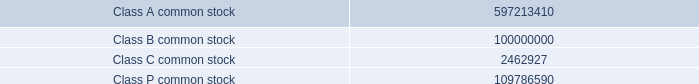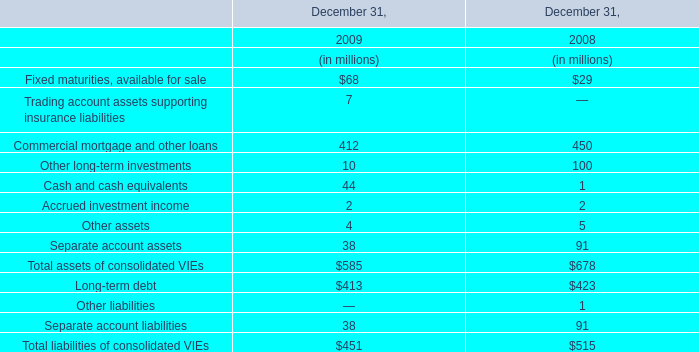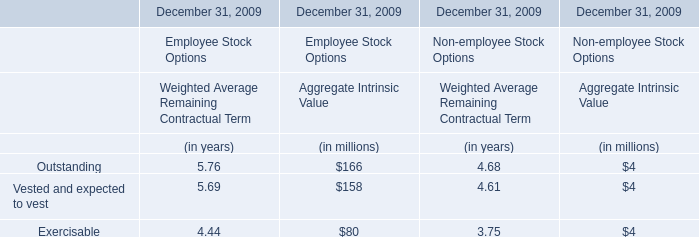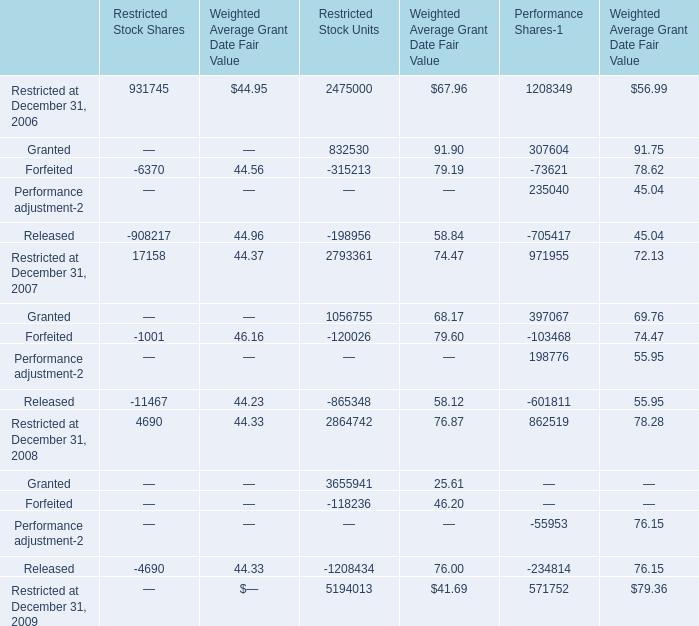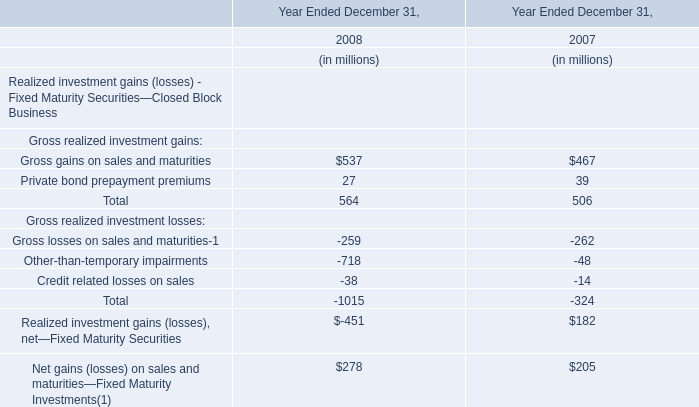What's the sum of all Aggregate Intrinsic Value that are positive in 2009 for Employee Stock Options ? (in million) 
Computations: ((166 + 158) + 80)
Answer: 404.0. 